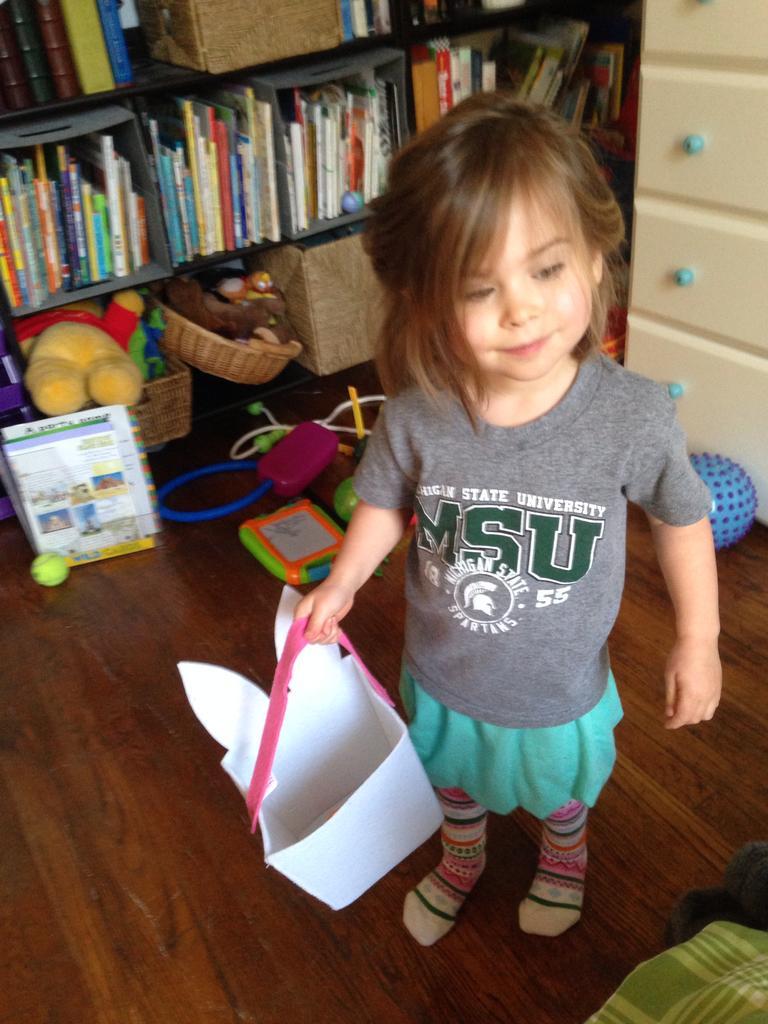Could you give a brief overview of what you see in this image? In this image we can see a kid and an object. In the background of the image there are books, toys, shelves and other objects. At the bottom of the image there is the floor. On the right side of the image there is an object. 